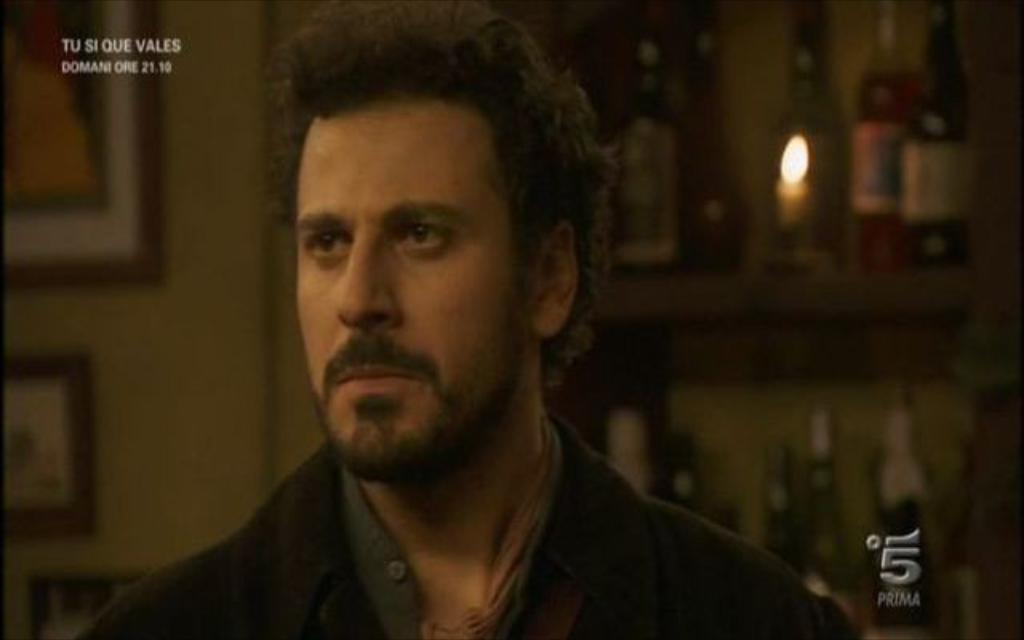What is the main subject of the image? There is a person in the image. What is the person wearing? The person is wearing a dress. What can be seen in the background of the image? There are frames on the wall in the background of the image. Can you identify any other objects in the image? Yes, there is a candle visible in the image. What songs are being played on the channel in the image? There is no channel or music player present in the image, so it is not possible to determine what songs might be playing. 